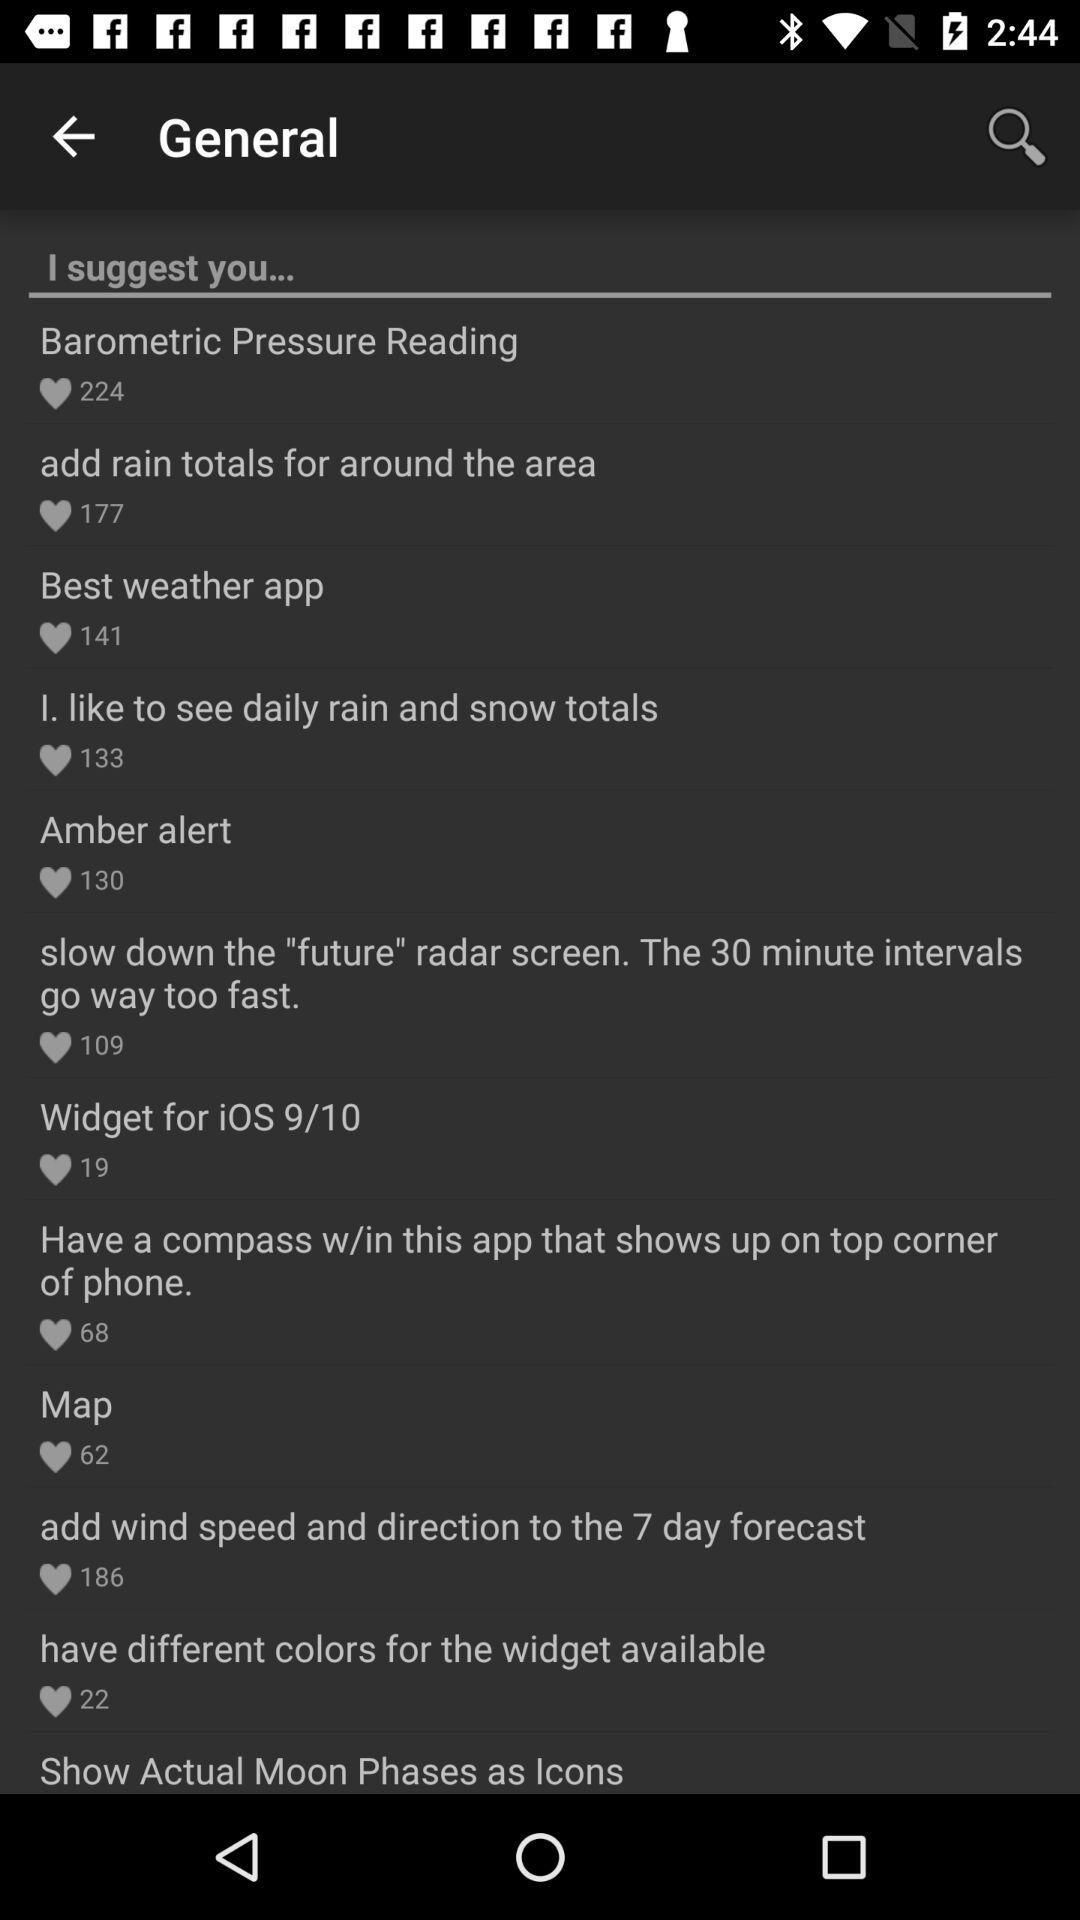How many people liked the "Barometric Pressure Reading"? The "Barometric Pressure Reading" is liked by 224 people. 